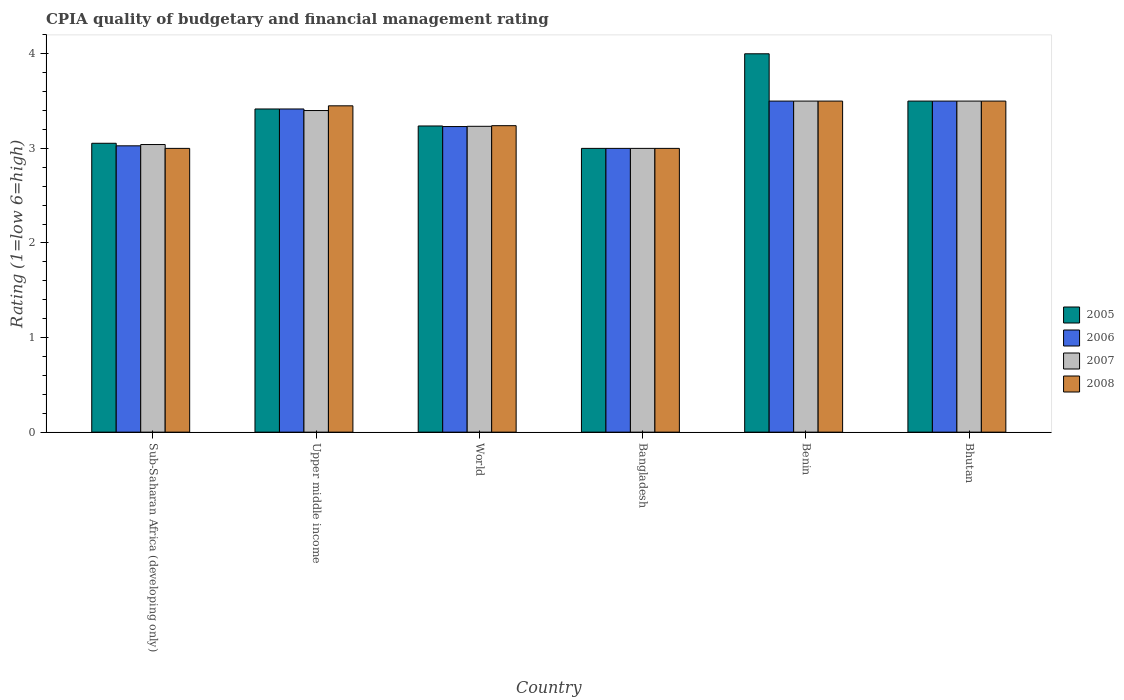How many bars are there on the 1st tick from the left?
Make the answer very short. 4. How many bars are there on the 1st tick from the right?
Provide a succinct answer. 4. What is the label of the 6th group of bars from the left?
Offer a very short reply. Bhutan. What is the CPIA rating in 2005 in World?
Your response must be concise. 3.24. Across all countries, what is the maximum CPIA rating in 2006?
Give a very brief answer. 3.5. In which country was the CPIA rating in 2006 maximum?
Provide a short and direct response. Benin. In which country was the CPIA rating in 2006 minimum?
Make the answer very short. Bangladesh. What is the total CPIA rating in 2008 in the graph?
Keep it short and to the point. 19.69. What is the difference between the CPIA rating in 2005 in Bhutan and that in Sub-Saharan Africa (developing only)?
Ensure brevity in your answer.  0.45. What is the average CPIA rating in 2006 per country?
Your answer should be compact. 3.28. In how many countries, is the CPIA rating in 2008 greater than 1?
Your response must be concise. 6. What is the ratio of the CPIA rating in 2007 in Benin to that in World?
Provide a short and direct response. 1.08. Is the CPIA rating in 2005 in Bhutan less than that in World?
Offer a terse response. No. What is the difference between the highest and the second highest CPIA rating in 2007?
Your answer should be compact. -0.1. Is it the case that in every country, the sum of the CPIA rating in 2005 and CPIA rating in 2006 is greater than the sum of CPIA rating in 2008 and CPIA rating in 2007?
Ensure brevity in your answer.  No. What does the 2nd bar from the right in Bangladesh represents?
Offer a very short reply. 2007. Is it the case that in every country, the sum of the CPIA rating in 2008 and CPIA rating in 2005 is greater than the CPIA rating in 2007?
Offer a terse response. Yes. Are all the bars in the graph horizontal?
Give a very brief answer. No. How many countries are there in the graph?
Keep it short and to the point. 6. Does the graph contain any zero values?
Offer a very short reply. No. Does the graph contain grids?
Your answer should be very brief. No. What is the title of the graph?
Provide a succinct answer. CPIA quality of budgetary and financial management rating. Does "1998" appear as one of the legend labels in the graph?
Provide a short and direct response. No. What is the label or title of the X-axis?
Make the answer very short. Country. What is the Rating (1=low 6=high) in 2005 in Sub-Saharan Africa (developing only)?
Your response must be concise. 3.05. What is the Rating (1=low 6=high) of 2006 in Sub-Saharan Africa (developing only)?
Provide a short and direct response. 3.03. What is the Rating (1=low 6=high) in 2007 in Sub-Saharan Africa (developing only)?
Your response must be concise. 3.04. What is the Rating (1=low 6=high) in 2005 in Upper middle income?
Your answer should be very brief. 3.42. What is the Rating (1=low 6=high) in 2006 in Upper middle income?
Your answer should be compact. 3.42. What is the Rating (1=low 6=high) of 2008 in Upper middle income?
Provide a short and direct response. 3.45. What is the Rating (1=low 6=high) of 2005 in World?
Your answer should be very brief. 3.24. What is the Rating (1=low 6=high) of 2006 in World?
Give a very brief answer. 3.23. What is the Rating (1=low 6=high) of 2007 in World?
Your answer should be very brief. 3.23. What is the Rating (1=low 6=high) of 2008 in World?
Make the answer very short. 3.24. What is the Rating (1=low 6=high) in 2007 in Bangladesh?
Your response must be concise. 3. What is the Rating (1=low 6=high) in 2008 in Bangladesh?
Your answer should be very brief. 3. What is the Rating (1=low 6=high) of 2005 in Benin?
Your answer should be compact. 4. What is the Rating (1=low 6=high) of 2006 in Benin?
Provide a short and direct response. 3.5. What is the Rating (1=low 6=high) in 2005 in Bhutan?
Your answer should be very brief. 3.5. What is the Rating (1=low 6=high) in 2007 in Bhutan?
Make the answer very short. 3.5. Across all countries, what is the maximum Rating (1=low 6=high) in 2006?
Your answer should be very brief. 3.5. Across all countries, what is the maximum Rating (1=low 6=high) in 2007?
Provide a short and direct response. 3.5. Across all countries, what is the maximum Rating (1=low 6=high) of 2008?
Your response must be concise. 3.5. Across all countries, what is the minimum Rating (1=low 6=high) of 2006?
Your answer should be compact. 3. Across all countries, what is the minimum Rating (1=low 6=high) in 2007?
Ensure brevity in your answer.  3. Across all countries, what is the minimum Rating (1=low 6=high) of 2008?
Provide a succinct answer. 3. What is the total Rating (1=low 6=high) in 2005 in the graph?
Your answer should be very brief. 20.21. What is the total Rating (1=low 6=high) of 2006 in the graph?
Make the answer very short. 19.67. What is the total Rating (1=low 6=high) in 2007 in the graph?
Offer a terse response. 19.67. What is the total Rating (1=low 6=high) in 2008 in the graph?
Provide a short and direct response. 19.69. What is the difference between the Rating (1=low 6=high) of 2005 in Sub-Saharan Africa (developing only) and that in Upper middle income?
Make the answer very short. -0.36. What is the difference between the Rating (1=low 6=high) in 2006 in Sub-Saharan Africa (developing only) and that in Upper middle income?
Keep it short and to the point. -0.39. What is the difference between the Rating (1=low 6=high) in 2007 in Sub-Saharan Africa (developing only) and that in Upper middle income?
Your answer should be compact. -0.36. What is the difference between the Rating (1=low 6=high) in 2008 in Sub-Saharan Africa (developing only) and that in Upper middle income?
Offer a terse response. -0.45. What is the difference between the Rating (1=low 6=high) of 2005 in Sub-Saharan Africa (developing only) and that in World?
Offer a terse response. -0.18. What is the difference between the Rating (1=low 6=high) of 2006 in Sub-Saharan Africa (developing only) and that in World?
Ensure brevity in your answer.  -0.2. What is the difference between the Rating (1=low 6=high) in 2007 in Sub-Saharan Africa (developing only) and that in World?
Make the answer very short. -0.19. What is the difference between the Rating (1=low 6=high) of 2008 in Sub-Saharan Africa (developing only) and that in World?
Ensure brevity in your answer.  -0.24. What is the difference between the Rating (1=low 6=high) of 2005 in Sub-Saharan Africa (developing only) and that in Bangladesh?
Provide a short and direct response. 0.05. What is the difference between the Rating (1=low 6=high) of 2006 in Sub-Saharan Africa (developing only) and that in Bangladesh?
Give a very brief answer. 0.03. What is the difference between the Rating (1=low 6=high) in 2007 in Sub-Saharan Africa (developing only) and that in Bangladesh?
Your answer should be compact. 0.04. What is the difference between the Rating (1=low 6=high) in 2005 in Sub-Saharan Africa (developing only) and that in Benin?
Your answer should be compact. -0.95. What is the difference between the Rating (1=low 6=high) of 2006 in Sub-Saharan Africa (developing only) and that in Benin?
Keep it short and to the point. -0.47. What is the difference between the Rating (1=low 6=high) in 2007 in Sub-Saharan Africa (developing only) and that in Benin?
Your response must be concise. -0.46. What is the difference between the Rating (1=low 6=high) of 2005 in Sub-Saharan Africa (developing only) and that in Bhutan?
Provide a succinct answer. -0.45. What is the difference between the Rating (1=low 6=high) in 2006 in Sub-Saharan Africa (developing only) and that in Bhutan?
Your response must be concise. -0.47. What is the difference between the Rating (1=low 6=high) in 2007 in Sub-Saharan Africa (developing only) and that in Bhutan?
Provide a short and direct response. -0.46. What is the difference between the Rating (1=low 6=high) in 2005 in Upper middle income and that in World?
Your response must be concise. 0.18. What is the difference between the Rating (1=low 6=high) of 2006 in Upper middle income and that in World?
Make the answer very short. 0.19. What is the difference between the Rating (1=low 6=high) in 2007 in Upper middle income and that in World?
Your answer should be compact. 0.17. What is the difference between the Rating (1=low 6=high) in 2008 in Upper middle income and that in World?
Offer a very short reply. 0.21. What is the difference between the Rating (1=low 6=high) in 2005 in Upper middle income and that in Bangladesh?
Ensure brevity in your answer.  0.42. What is the difference between the Rating (1=low 6=high) of 2006 in Upper middle income and that in Bangladesh?
Give a very brief answer. 0.42. What is the difference between the Rating (1=low 6=high) of 2007 in Upper middle income and that in Bangladesh?
Keep it short and to the point. 0.4. What is the difference between the Rating (1=low 6=high) of 2008 in Upper middle income and that in Bangladesh?
Offer a very short reply. 0.45. What is the difference between the Rating (1=low 6=high) in 2005 in Upper middle income and that in Benin?
Make the answer very short. -0.58. What is the difference between the Rating (1=low 6=high) of 2006 in Upper middle income and that in Benin?
Your answer should be compact. -0.08. What is the difference between the Rating (1=low 6=high) in 2005 in Upper middle income and that in Bhutan?
Offer a terse response. -0.08. What is the difference between the Rating (1=low 6=high) of 2006 in Upper middle income and that in Bhutan?
Provide a succinct answer. -0.08. What is the difference between the Rating (1=low 6=high) of 2007 in Upper middle income and that in Bhutan?
Give a very brief answer. -0.1. What is the difference between the Rating (1=low 6=high) in 2005 in World and that in Bangladesh?
Provide a succinct answer. 0.24. What is the difference between the Rating (1=low 6=high) in 2006 in World and that in Bangladesh?
Keep it short and to the point. 0.23. What is the difference between the Rating (1=low 6=high) in 2007 in World and that in Bangladesh?
Give a very brief answer. 0.23. What is the difference between the Rating (1=low 6=high) of 2008 in World and that in Bangladesh?
Keep it short and to the point. 0.24. What is the difference between the Rating (1=low 6=high) in 2005 in World and that in Benin?
Provide a succinct answer. -0.76. What is the difference between the Rating (1=low 6=high) of 2006 in World and that in Benin?
Ensure brevity in your answer.  -0.27. What is the difference between the Rating (1=low 6=high) of 2007 in World and that in Benin?
Provide a succinct answer. -0.27. What is the difference between the Rating (1=low 6=high) of 2008 in World and that in Benin?
Your answer should be compact. -0.26. What is the difference between the Rating (1=low 6=high) in 2005 in World and that in Bhutan?
Provide a succinct answer. -0.26. What is the difference between the Rating (1=low 6=high) in 2006 in World and that in Bhutan?
Keep it short and to the point. -0.27. What is the difference between the Rating (1=low 6=high) of 2007 in World and that in Bhutan?
Provide a succinct answer. -0.27. What is the difference between the Rating (1=low 6=high) in 2008 in World and that in Bhutan?
Make the answer very short. -0.26. What is the difference between the Rating (1=low 6=high) of 2005 in Bangladesh and that in Benin?
Make the answer very short. -1. What is the difference between the Rating (1=low 6=high) in 2007 in Bangladesh and that in Benin?
Keep it short and to the point. -0.5. What is the difference between the Rating (1=low 6=high) in 2008 in Bangladesh and that in Benin?
Your response must be concise. -0.5. What is the difference between the Rating (1=low 6=high) of 2005 in Bangladesh and that in Bhutan?
Make the answer very short. -0.5. What is the difference between the Rating (1=low 6=high) of 2006 in Bangladesh and that in Bhutan?
Give a very brief answer. -0.5. What is the difference between the Rating (1=low 6=high) of 2007 in Bangladesh and that in Bhutan?
Your response must be concise. -0.5. What is the difference between the Rating (1=low 6=high) in 2008 in Bangladesh and that in Bhutan?
Ensure brevity in your answer.  -0.5. What is the difference between the Rating (1=low 6=high) in 2006 in Benin and that in Bhutan?
Ensure brevity in your answer.  0. What is the difference between the Rating (1=low 6=high) in 2007 in Benin and that in Bhutan?
Offer a very short reply. 0. What is the difference between the Rating (1=low 6=high) of 2005 in Sub-Saharan Africa (developing only) and the Rating (1=low 6=high) of 2006 in Upper middle income?
Make the answer very short. -0.36. What is the difference between the Rating (1=low 6=high) in 2005 in Sub-Saharan Africa (developing only) and the Rating (1=low 6=high) in 2007 in Upper middle income?
Offer a very short reply. -0.35. What is the difference between the Rating (1=low 6=high) in 2005 in Sub-Saharan Africa (developing only) and the Rating (1=low 6=high) in 2008 in Upper middle income?
Your response must be concise. -0.4. What is the difference between the Rating (1=low 6=high) in 2006 in Sub-Saharan Africa (developing only) and the Rating (1=low 6=high) in 2007 in Upper middle income?
Provide a succinct answer. -0.37. What is the difference between the Rating (1=low 6=high) of 2006 in Sub-Saharan Africa (developing only) and the Rating (1=low 6=high) of 2008 in Upper middle income?
Your answer should be compact. -0.42. What is the difference between the Rating (1=low 6=high) in 2007 in Sub-Saharan Africa (developing only) and the Rating (1=low 6=high) in 2008 in Upper middle income?
Offer a terse response. -0.41. What is the difference between the Rating (1=low 6=high) in 2005 in Sub-Saharan Africa (developing only) and the Rating (1=low 6=high) in 2006 in World?
Give a very brief answer. -0.18. What is the difference between the Rating (1=low 6=high) of 2005 in Sub-Saharan Africa (developing only) and the Rating (1=low 6=high) of 2007 in World?
Provide a succinct answer. -0.18. What is the difference between the Rating (1=low 6=high) of 2005 in Sub-Saharan Africa (developing only) and the Rating (1=low 6=high) of 2008 in World?
Your answer should be very brief. -0.19. What is the difference between the Rating (1=low 6=high) in 2006 in Sub-Saharan Africa (developing only) and the Rating (1=low 6=high) in 2007 in World?
Make the answer very short. -0.21. What is the difference between the Rating (1=low 6=high) in 2006 in Sub-Saharan Africa (developing only) and the Rating (1=low 6=high) in 2008 in World?
Offer a terse response. -0.21. What is the difference between the Rating (1=low 6=high) in 2007 in Sub-Saharan Africa (developing only) and the Rating (1=low 6=high) in 2008 in World?
Provide a short and direct response. -0.2. What is the difference between the Rating (1=low 6=high) of 2005 in Sub-Saharan Africa (developing only) and the Rating (1=low 6=high) of 2006 in Bangladesh?
Your answer should be very brief. 0.05. What is the difference between the Rating (1=low 6=high) of 2005 in Sub-Saharan Africa (developing only) and the Rating (1=low 6=high) of 2007 in Bangladesh?
Provide a short and direct response. 0.05. What is the difference between the Rating (1=low 6=high) of 2005 in Sub-Saharan Africa (developing only) and the Rating (1=low 6=high) of 2008 in Bangladesh?
Give a very brief answer. 0.05. What is the difference between the Rating (1=low 6=high) of 2006 in Sub-Saharan Africa (developing only) and the Rating (1=low 6=high) of 2007 in Bangladesh?
Offer a terse response. 0.03. What is the difference between the Rating (1=low 6=high) of 2006 in Sub-Saharan Africa (developing only) and the Rating (1=low 6=high) of 2008 in Bangladesh?
Your answer should be compact. 0.03. What is the difference between the Rating (1=low 6=high) in 2007 in Sub-Saharan Africa (developing only) and the Rating (1=low 6=high) in 2008 in Bangladesh?
Your answer should be compact. 0.04. What is the difference between the Rating (1=low 6=high) in 2005 in Sub-Saharan Africa (developing only) and the Rating (1=low 6=high) in 2006 in Benin?
Keep it short and to the point. -0.45. What is the difference between the Rating (1=low 6=high) of 2005 in Sub-Saharan Africa (developing only) and the Rating (1=low 6=high) of 2007 in Benin?
Your answer should be compact. -0.45. What is the difference between the Rating (1=low 6=high) in 2005 in Sub-Saharan Africa (developing only) and the Rating (1=low 6=high) in 2008 in Benin?
Make the answer very short. -0.45. What is the difference between the Rating (1=low 6=high) in 2006 in Sub-Saharan Africa (developing only) and the Rating (1=low 6=high) in 2007 in Benin?
Give a very brief answer. -0.47. What is the difference between the Rating (1=low 6=high) of 2006 in Sub-Saharan Africa (developing only) and the Rating (1=low 6=high) of 2008 in Benin?
Provide a short and direct response. -0.47. What is the difference between the Rating (1=low 6=high) in 2007 in Sub-Saharan Africa (developing only) and the Rating (1=low 6=high) in 2008 in Benin?
Offer a terse response. -0.46. What is the difference between the Rating (1=low 6=high) in 2005 in Sub-Saharan Africa (developing only) and the Rating (1=low 6=high) in 2006 in Bhutan?
Ensure brevity in your answer.  -0.45. What is the difference between the Rating (1=low 6=high) in 2005 in Sub-Saharan Africa (developing only) and the Rating (1=low 6=high) in 2007 in Bhutan?
Your response must be concise. -0.45. What is the difference between the Rating (1=low 6=high) of 2005 in Sub-Saharan Africa (developing only) and the Rating (1=low 6=high) of 2008 in Bhutan?
Ensure brevity in your answer.  -0.45. What is the difference between the Rating (1=low 6=high) of 2006 in Sub-Saharan Africa (developing only) and the Rating (1=low 6=high) of 2007 in Bhutan?
Keep it short and to the point. -0.47. What is the difference between the Rating (1=low 6=high) in 2006 in Sub-Saharan Africa (developing only) and the Rating (1=low 6=high) in 2008 in Bhutan?
Make the answer very short. -0.47. What is the difference between the Rating (1=low 6=high) in 2007 in Sub-Saharan Africa (developing only) and the Rating (1=low 6=high) in 2008 in Bhutan?
Ensure brevity in your answer.  -0.46. What is the difference between the Rating (1=low 6=high) of 2005 in Upper middle income and the Rating (1=low 6=high) of 2006 in World?
Your answer should be very brief. 0.19. What is the difference between the Rating (1=low 6=high) of 2005 in Upper middle income and the Rating (1=low 6=high) of 2007 in World?
Your answer should be compact. 0.18. What is the difference between the Rating (1=low 6=high) of 2005 in Upper middle income and the Rating (1=low 6=high) of 2008 in World?
Your answer should be compact. 0.18. What is the difference between the Rating (1=low 6=high) of 2006 in Upper middle income and the Rating (1=low 6=high) of 2007 in World?
Provide a succinct answer. 0.18. What is the difference between the Rating (1=low 6=high) in 2006 in Upper middle income and the Rating (1=low 6=high) in 2008 in World?
Offer a very short reply. 0.18. What is the difference between the Rating (1=low 6=high) in 2007 in Upper middle income and the Rating (1=low 6=high) in 2008 in World?
Ensure brevity in your answer.  0.16. What is the difference between the Rating (1=low 6=high) of 2005 in Upper middle income and the Rating (1=low 6=high) of 2006 in Bangladesh?
Your response must be concise. 0.42. What is the difference between the Rating (1=low 6=high) in 2005 in Upper middle income and the Rating (1=low 6=high) in 2007 in Bangladesh?
Your answer should be compact. 0.42. What is the difference between the Rating (1=low 6=high) in 2005 in Upper middle income and the Rating (1=low 6=high) in 2008 in Bangladesh?
Provide a succinct answer. 0.42. What is the difference between the Rating (1=low 6=high) of 2006 in Upper middle income and the Rating (1=low 6=high) of 2007 in Bangladesh?
Offer a terse response. 0.42. What is the difference between the Rating (1=low 6=high) of 2006 in Upper middle income and the Rating (1=low 6=high) of 2008 in Bangladesh?
Give a very brief answer. 0.42. What is the difference between the Rating (1=low 6=high) in 2005 in Upper middle income and the Rating (1=low 6=high) in 2006 in Benin?
Your answer should be very brief. -0.08. What is the difference between the Rating (1=low 6=high) of 2005 in Upper middle income and the Rating (1=low 6=high) of 2007 in Benin?
Your answer should be very brief. -0.08. What is the difference between the Rating (1=low 6=high) in 2005 in Upper middle income and the Rating (1=low 6=high) in 2008 in Benin?
Your response must be concise. -0.08. What is the difference between the Rating (1=low 6=high) of 2006 in Upper middle income and the Rating (1=low 6=high) of 2007 in Benin?
Provide a short and direct response. -0.08. What is the difference between the Rating (1=low 6=high) of 2006 in Upper middle income and the Rating (1=low 6=high) of 2008 in Benin?
Your answer should be compact. -0.08. What is the difference between the Rating (1=low 6=high) of 2005 in Upper middle income and the Rating (1=low 6=high) of 2006 in Bhutan?
Make the answer very short. -0.08. What is the difference between the Rating (1=low 6=high) of 2005 in Upper middle income and the Rating (1=low 6=high) of 2007 in Bhutan?
Provide a succinct answer. -0.08. What is the difference between the Rating (1=low 6=high) of 2005 in Upper middle income and the Rating (1=low 6=high) of 2008 in Bhutan?
Offer a terse response. -0.08. What is the difference between the Rating (1=low 6=high) of 2006 in Upper middle income and the Rating (1=low 6=high) of 2007 in Bhutan?
Your answer should be compact. -0.08. What is the difference between the Rating (1=low 6=high) in 2006 in Upper middle income and the Rating (1=low 6=high) in 2008 in Bhutan?
Make the answer very short. -0.08. What is the difference between the Rating (1=low 6=high) in 2007 in Upper middle income and the Rating (1=low 6=high) in 2008 in Bhutan?
Your answer should be very brief. -0.1. What is the difference between the Rating (1=low 6=high) of 2005 in World and the Rating (1=low 6=high) of 2006 in Bangladesh?
Your response must be concise. 0.24. What is the difference between the Rating (1=low 6=high) in 2005 in World and the Rating (1=low 6=high) in 2007 in Bangladesh?
Your response must be concise. 0.24. What is the difference between the Rating (1=low 6=high) of 2005 in World and the Rating (1=low 6=high) of 2008 in Bangladesh?
Give a very brief answer. 0.24. What is the difference between the Rating (1=low 6=high) of 2006 in World and the Rating (1=low 6=high) of 2007 in Bangladesh?
Offer a terse response. 0.23. What is the difference between the Rating (1=low 6=high) of 2006 in World and the Rating (1=low 6=high) of 2008 in Bangladesh?
Keep it short and to the point. 0.23. What is the difference between the Rating (1=low 6=high) of 2007 in World and the Rating (1=low 6=high) of 2008 in Bangladesh?
Provide a short and direct response. 0.23. What is the difference between the Rating (1=low 6=high) of 2005 in World and the Rating (1=low 6=high) of 2006 in Benin?
Your response must be concise. -0.26. What is the difference between the Rating (1=low 6=high) in 2005 in World and the Rating (1=low 6=high) in 2007 in Benin?
Provide a short and direct response. -0.26. What is the difference between the Rating (1=low 6=high) in 2005 in World and the Rating (1=low 6=high) in 2008 in Benin?
Your answer should be compact. -0.26. What is the difference between the Rating (1=low 6=high) of 2006 in World and the Rating (1=low 6=high) of 2007 in Benin?
Your answer should be very brief. -0.27. What is the difference between the Rating (1=low 6=high) in 2006 in World and the Rating (1=low 6=high) in 2008 in Benin?
Your response must be concise. -0.27. What is the difference between the Rating (1=low 6=high) in 2007 in World and the Rating (1=low 6=high) in 2008 in Benin?
Provide a succinct answer. -0.27. What is the difference between the Rating (1=low 6=high) in 2005 in World and the Rating (1=low 6=high) in 2006 in Bhutan?
Provide a succinct answer. -0.26. What is the difference between the Rating (1=low 6=high) of 2005 in World and the Rating (1=low 6=high) of 2007 in Bhutan?
Ensure brevity in your answer.  -0.26. What is the difference between the Rating (1=low 6=high) in 2005 in World and the Rating (1=low 6=high) in 2008 in Bhutan?
Offer a terse response. -0.26. What is the difference between the Rating (1=low 6=high) of 2006 in World and the Rating (1=low 6=high) of 2007 in Bhutan?
Give a very brief answer. -0.27. What is the difference between the Rating (1=low 6=high) of 2006 in World and the Rating (1=low 6=high) of 2008 in Bhutan?
Make the answer very short. -0.27. What is the difference between the Rating (1=low 6=high) of 2007 in World and the Rating (1=low 6=high) of 2008 in Bhutan?
Your answer should be compact. -0.27. What is the difference between the Rating (1=low 6=high) of 2005 in Bangladesh and the Rating (1=low 6=high) of 2007 in Benin?
Make the answer very short. -0.5. What is the difference between the Rating (1=low 6=high) of 2006 in Bangladesh and the Rating (1=low 6=high) of 2007 in Benin?
Your answer should be very brief. -0.5. What is the difference between the Rating (1=low 6=high) of 2006 in Bangladesh and the Rating (1=low 6=high) of 2008 in Benin?
Provide a short and direct response. -0.5. What is the difference between the Rating (1=low 6=high) of 2005 in Bangladesh and the Rating (1=low 6=high) of 2008 in Bhutan?
Your response must be concise. -0.5. What is the difference between the Rating (1=low 6=high) in 2006 in Bangladesh and the Rating (1=low 6=high) in 2007 in Bhutan?
Give a very brief answer. -0.5. What is the average Rating (1=low 6=high) of 2005 per country?
Ensure brevity in your answer.  3.37. What is the average Rating (1=low 6=high) of 2006 per country?
Give a very brief answer. 3.28. What is the average Rating (1=low 6=high) in 2007 per country?
Provide a short and direct response. 3.28. What is the average Rating (1=low 6=high) in 2008 per country?
Provide a succinct answer. 3.28. What is the difference between the Rating (1=low 6=high) of 2005 and Rating (1=low 6=high) of 2006 in Sub-Saharan Africa (developing only)?
Your answer should be compact. 0.03. What is the difference between the Rating (1=low 6=high) in 2005 and Rating (1=low 6=high) in 2007 in Sub-Saharan Africa (developing only)?
Your answer should be very brief. 0.01. What is the difference between the Rating (1=low 6=high) of 2005 and Rating (1=low 6=high) of 2008 in Sub-Saharan Africa (developing only)?
Your answer should be compact. 0.05. What is the difference between the Rating (1=low 6=high) in 2006 and Rating (1=low 6=high) in 2007 in Sub-Saharan Africa (developing only)?
Provide a succinct answer. -0.01. What is the difference between the Rating (1=low 6=high) of 2006 and Rating (1=low 6=high) of 2008 in Sub-Saharan Africa (developing only)?
Your response must be concise. 0.03. What is the difference between the Rating (1=low 6=high) of 2007 and Rating (1=low 6=high) of 2008 in Sub-Saharan Africa (developing only)?
Offer a terse response. 0.04. What is the difference between the Rating (1=low 6=high) in 2005 and Rating (1=low 6=high) in 2007 in Upper middle income?
Your answer should be compact. 0.02. What is the difference between the Rating (1=low 6=high) in 2005 and Rating (1=low 6=high) in 2008 in Upper middle income?
Offer a very short reply. -0.03. What is the difference between the Rating (1=low 6=high) in 2006 and Rating (1=low 6=high) in 2007 in Upper middle income?
Your answer should be very brief. 0.02. What is the difference between the Rating (1=low 6=high) of 2006 and Rating (1=low 6=high) of 2008 in Upper middle income?
Offer a terse response. -0.03. What is the difference between the Rating (1=low 6=high) of 2007 and Rating (1=low 6=high) of 2008 in Upper middle income?
Give a very brief answer. -0.05. What is the difference between the Rating (1=low 6=high) in 2005 and Rating (1=low 6=high) in 2006 in World?
Provide a short and direct response. 0.01. What is the difference between the Rating (1=low 6=high) of 2005 and Rating (1=low 6=high) of 2007 in World?
Provide a short and direct response. 0. What is the difference between the Rating (1=low 6=high) in 2005 and Rating (1=low 6=high) in 2008 in World?
Provide a short and direct response. -0. What is the difference between the Rating (1=low 6=high) of 2006 and Rating (1=low 6=high) of 2007 in World?
Ensure brevity in your answer.  -0. What is the difference between the Rating (1=low 6=high) in 2006 and Rating (1=low 6=high) in 2008 in World?
Provide a short and direct response. -0.01. What is the difference between the Rating (1=low 6=high) in 2007 and Rating (1=low 6=high) in 2008 in World?
Your answer should be compact. -0.01. What is the difference between the Rating (1=low 6=high) of 2005 and Rating (1=low 6=high) of 2006 in Bangladesh?
Keep it short and to the point. 0. What is the difference between the Rating (1=low 6=high) in 2005 and Rating (1=low 6=high) in 2008 in Bangladesh?
Your answer should be compact. 0. What is the difference between the Rating (1=low 6=high) of 2006 and Rating (1=low 6=high) of 2007 in Bangladesh?
Keep it short and to the point. 0. What is the difference between the Rating (1=low 6=high) of 2005 and Rating (1=low 6=high) of 2006 in Benin?
Your answer should be very brief. 0.5. What is the difference between the Rating (1=low 6=high) in 2007 and Rating (1=low 6=high) in 2008 in Benin?
Offer a terse response. 0. What is the difference between the Rating (1=low 6=high) in 2005 and Rating (1=low 6=high) in 2007 in Bhutan?
Give a very brief answer. 0. What is the difference between the Rating (1=low 6=high) of 2005 and Rating (1=low 6=high) of 2008 in Bhutan?
Your answer should be very brief. 0. What is the difference between the Rating (1=low 6=high) in 2006 and Rating (1=low 6=high) in 2008 in Bhutan?
Your answer should be compact. 0. What is the difference between the Rating (1=low 6=high) in 2007 and Rating (1=low 6=high) in 2008 in Bhutan?
Provide a short and direct response. 0. What is the ratio of the Rating (1=low 6=high) of 2005 in Sub-Saharan Africa (developing only) to that in Upper middle income?
Provide a short and direct response. 0.89. What is the ratio of the Rating (1=low 6=high) in 2006 in Sub-Saharan Africa (developing only) to that in Upper middle income?
Offer a terse response. 0.89. What is the ratio of the Rating (1=low 6=high) in 2007 in Sub-Saharan Africa (developing only) to that in Upper middle income?
Offer a very short reply. 0.89. What is the ratio of the Rating (1=low 6=high) in 2008 in Sub-Saharan Africa (developing only) to that in Upper middle income?
Your answer should be very brief. 0.87. What is the ratio of the Rating (1=low 6=high) in 2005 in Sub-Saharan Africa (developing only) to that in World?
Keep it short and to the point. 0.94. What is the ratio of the Rating (1=low 6=high) of 2006 in Sub-Saharan Africa (developing only) to that in World?
Give a very brief answer. 0.94. What is the ratio of the Rating (1=low 6=high) in 2007 in Sub-Saharan Africa (developing only) to that in World?
Your answer should be very brief. 0.94. What is the ratio of the Rating (1=low 6=high) in 2008 in Sub-Saharan Africa (developing only) to that in World?
Your response must be concise. 0.93. What is the ratio of the Rating (1=low 6=high) of 2006 in Sub-Saharan Africa (developing only) to that in Bangladesh?
Ensure brevity in your answer.  1.01. What is the ratio of the Rating (1=low 6=high) in 2007 in Sub-Saharan Africa (developing only) to that in Bangladesh?
Offer a terse response. 1.01. What is the ratio of the Rating (1=low 6=high) in 2005 in Sub-Saharan Africa (developing only) to that in Benin?
Keep it short and to the point. 0.76. What is the ratio of the Rating (1=low 6=high) in 2006 in Sub-Saharan Africa (developing only) to that in Benin?
Your response must be concise. 0.86. What is the ratio of the Rating (1=low 6=high) of 2007 in Sub-Saharan Africa (developing only) to that in Benin?
Your answer should be very brief. 0.87. What is the ratio of the Rating (1=low 6=high) in 2008 in Sub-Saharan Africa (developing only) to that in Benin?
Make the answer very short. 0.86. What is the ratio of the Rating (1=low 6=high) of 2005 in Sub-Saharan Africa (developing only) to that in Bhutan?
Your answer should be compact. 0.87. What is the ratio of the Rating (1=low 6=high) in 2006 in Sub-Saharan Africa (developing only) to that in Bhutan?
Give a very brief answer. 0.86. What is the ratio of the Rating (1=low 6=high) in 2007 in Sub-Saharan Africa (developing only) to that in Bhutan?
Make the answer very short. 0.87. What is the ratio of the Rating (1=low 6=high) of 2005 in Upper middle income to that in World?
Keep it short and to the point. 1.06. What is the ratio of the Rating (1=low 6=high) in 2006 in Upper middle income to that in World?
Give a very brief answer. 1.06. What is the ratio of the Rating (1=low 6=high) in 2007 in Upper middle income to that in World?
Give a very brief answer. 1.05. What is the ratio of the Rating (1=low 6=high) of 2008 in Upper middle income to that in World?
Your answer should be very brief. 1.06. What is the ratio of the Rating (1=low 6=high) in 2005 in Upper middle income to that in Bangladesh?
Provide a succinct answer. 1.14. What is the ratio of the Rating (1=low 6=high) of 2006 in Upper middle income to that in Bangladesh?
Your response must be concise. 1.14. What is the ratio of the Rating (1=low 6=high) of 2007 in Upper middle income to that in Bangladesh?
Provide a succinct answer. 1.13. What is the ratio of the Rating (1=low 6=high) of 2008 in Upper middle income to that in Bangladesh?
Ensure brevity in your answer.  1.15. What is the ratio of the Rating (1=low 6=high) of 2005 in Upper middle income to that in Benin?
Ensure brevity in your answer.  0.85. What is the ratio of the Rating (1=low 6=high) of 2006 in Upper middle income to that in Benin?
Your answer should be very brief. 0.98. What is the ratio of the Rating (1=low 6=high) of 2007 in Upper middle income to that in Benin?
Your answer should be very brief. 0.97. What is the ratio of the Rating (1=low 6=high) of 2008 in Upper middle income to that in Benin?
Your response must be concise. 0.99. What is the ratio of the Rating (1=low 6=high) in 2005 in Upper middle income to that in Bhutan?
Your answer should be very brief. 0.98. What is the ratio of the Rating (1=low 6=high) of 2006 in Upper middle income to that in Bhutan?
Give a very brief answer. 0.98. What is the ratio of the Rating (1=low 6=high) of 2007 in Upper middle income to that in Bhutan?
Give a very brief answer. 0.97. What is the ratio of the Rating (1=low 6=high) of 2008 in Upper middle income to that in Bhutan?
Ensure brevity in your answer.  0.99. What is the ratio of the Rating (1=low 6=high) of 2005 in World to that in Bangladesh?
Your answer should be very brief. 1.08. What is the ratio of the Rating (1=low 6=high) in 2006 in World to that in Bangladesh?
Give a very brief answer. 1.08. What is the ratio of the Rating (1=low 6=high) of 2007 in World to that in Bangladesh?
Provide a short and direct response. 1.08. What is the ratio of the Rating (1=low 6=high) in 2008 in World to that in Bangladesh?
Your response must be concise. 1.08. What is the ratio of the Rating (1=low 6=high) in 2005 in World to that in Benin?
Keep it short and to the point. 0.81. What is the ratio of the Rating (1=low 6=high) of 2007 in World to that in Benin?
Provide a short and direct response. 0.92. What is the ratio of the Rating (1=low 6=high) of 2008 in World to that in Benin?
Offer a very short reply. 0.93. What is the ratio of the Rating (1=low 6=high) of 2005 in World to that in Bhutan?
Your answer should be compact. 0.92. What is the ratio of the Rating (1=low 6=high) in 2007 in World to that in Bhutan?
Ensure brevity in your answer.  0.92. What is the ratio of the Rating (1=low 6=high) in 2008 in World to that in Bhutan?
Offer a terse response. 0.93. What is the ratio of the Rating (1=low 6=high) in 2007 in Bangladesh to that in Benin?
Provide a short and direct response. 0.86. What is the ratio of the Rating (1=low 6=high) in 2005 in Bangladesh to that in Bhutan?
Your response must be concise. 0.86. What is the ratio of the Rating (1=low 6=high) in 2006 in Bangladesh to that in Bhutan?
Offer a terse response. 0.86. What is the ratio of the Rating (1=low 6=high) of 2007 in Bangladesh to that in Bhutan?
Offer a terse response. 0.86. What is the ratio of the Rating (1=low 6=high) in 2007 in Benin to that in Bhutan?
Offer a very short reply. 1. What is the ratio of the Rating (1=low 6=high) of 2008 in Benin to that in Bhutan?
Your answer should be compact. 1. What is the difference between the highest and the second highest Rating (1=low 6=high) of 2005?
Your response must be concise. 0.5. What is the difference between the highest and the second highest Rating (1=low 6=high) of 2007?
Your answer should be very brief. 0. What is the difference between the highest and the second highest Rating (1=low 6=high) in 2008?
Offer a terse response. 0. What is the difference between the highest and the lowest Rating (1=low 6=high) in 2006?
Provide a succinct answer. 0.5. What is the difference between the highest and the lowest Rating (1=low 6=high) of 2008?
Ensure brevity in your answer.  0.5. 